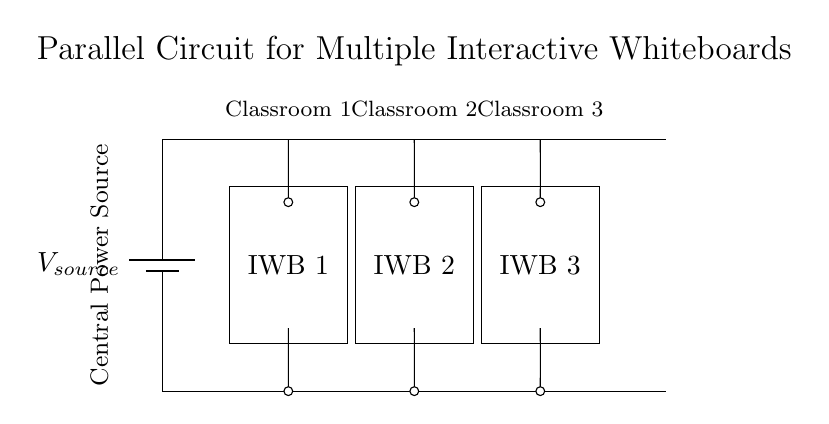What is the central power source? The circuit diagram illustrates the central power source as a battery labeled "Vsource," which supplies voltage to the connected components.
Answer: Battery How many interactive whiteboards are connected? The diagram shows three distinct rectangles labeled "IWB 1", "IWB 2", and "IWB 3", indicating three interactive whiteboards are connected.
Answer: Three What is the type of this circuit configuration? The configuration shows multiple paths for current to flow to the interactive whiteboards, indicating it is a parallel circuit.
Answer: Parallel What do the short lines represent in the circuit? The short lines in the circuit diagram represent connections to the interactive whiteboards, allowing for branching off from the main power line to each IWB.
Answer: Connections If one interactive whiteboard fails, what happens to the others? In a parallel circuit, if one component fails, the other branches remain operational because each IWB is independently connected to the power source.
Answer: Remain operational What voltage do all the interactive whiteboards receive? In a parallel circuit, all components receive the same voltage provided by the power source, which is indicated as "Vsource" in the diagram for all IWBs.
Answer: Vsource 